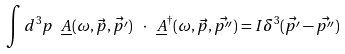Convert formula to latex. <formula><loc_0><loc_0><loc_500><loc_500>\int d ^ { 3 } p \ \underline { A } ( \omega , \vec { p } , \vec { p ^ { \prime } } ) \ \cdot \ \underline { A } ^ { \dag } ( \omega , \vec { p } , \vec { p ^ { \prime \prime } } ) = I \delta ^ { 3 } ( \vec { p ^ { \prime } } - \vec { p ^ { \prime \prime } } )</formula> 